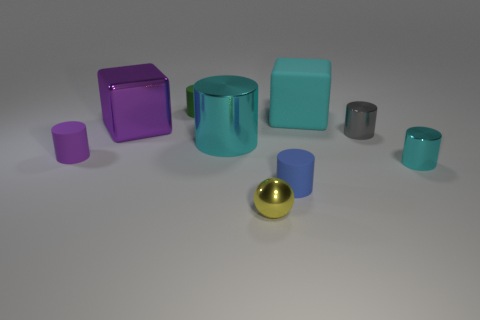Subtract all blue rubber cylinders. How many cylinders are left? 5 Subtract 1 cylinders. How many cylinders are left? 5 Subtract all blue cylinders. How many cylinders are left? 5 Subtract all gray cylinders. Subtract all yellow spheres. How many cylinders are left? 5 Add 1 large cyan metallic cubes. How many objects exist? 10 Subtract all spheres. How many objects are left? 8 Subtract all tiny cyan cylinders. Subtract all big cyan cubes. How many objects are left? 7 Add 7 cyan matte cubes. How many cyan matte cubes are left? 8 Add 9 small gray rubber spheres. How many small gray rubber spheres exist? 9 Subtract 1 cyan cubes. How many objects are left? 8 